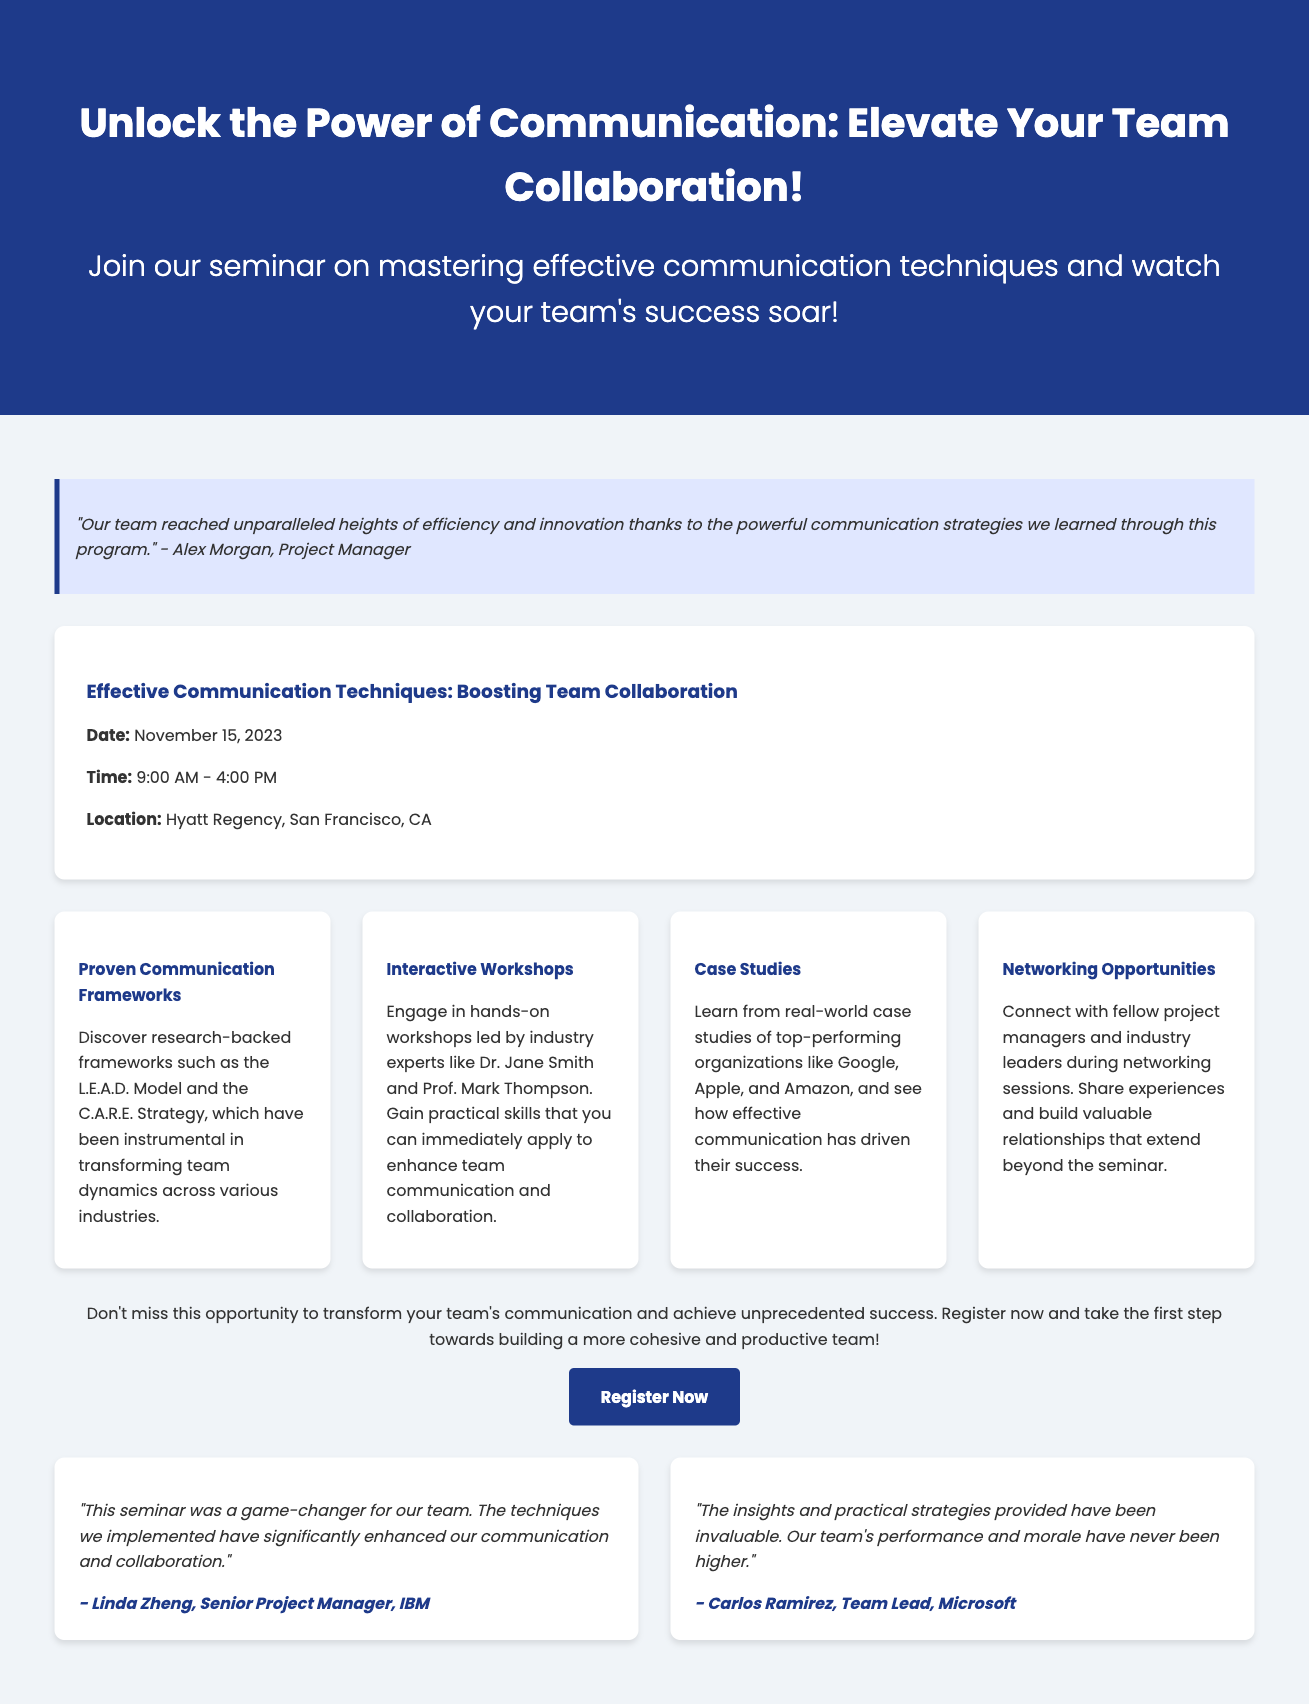What is the seminar date? The seminar date is explicitly mentioned in the event details section of the document.
Answer: November 15, 2023 What time does the seminar start? The start time is clearly stated in the event details section of the document.
Answer: 9:00 AM Where is the seminar location? The location of the seminar is specified in the event details section of the document.
Answer: Hyatt Regency, San Francisco, CA Who are the industry experts leading the workshops? The document lists the names of experts conducting the workshops under seminar highlights.
Answer: Dr. Jane Smith and Prof. Mark Thompson What model is mentioned as part of the communication frameworks? The document references a specific model related to communication frameworks.
Answer: L.E.A.D. Model What type of session is highlighted for networking? The document includes the nature of the sessions aimed at networking opportunities.
Answer: Networking sessions Who is the quote attributed to in the document? The quote presented in the document is credited to a specific individual.
Answer: Alex Morgan How long is the seminar scheduled to last? The total time duration of the seminar can be inferred from the start and end times provided.
Answer: 7 hours What is the main goal of the seminar? The document communicates the overall purpose of the seminar in the title section.
Answer: Mastering effective communication techniques 